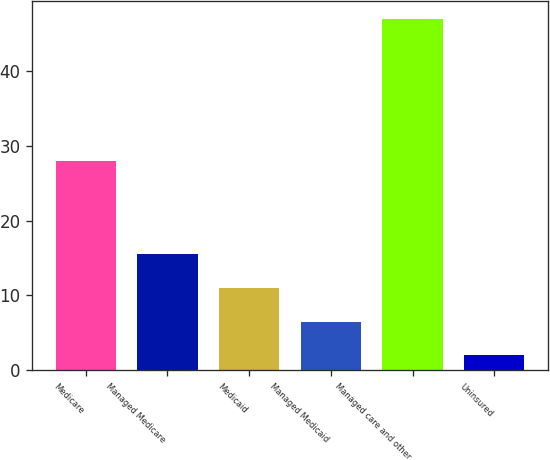Convert chart. <chart><loc_0><loc_0><loc_500><loc_500><bar_chart><fcel>Medicare<fcel>Managed Medicare<fcel>Medicaid<fcel>Managed Medicaid<fcel>Managed care and other<fcel>Uninsured<nl><fcel>28<fcel>15.5<fcel>11<fcel>6.5<fcel>47<fcel>2<nl></chart> 